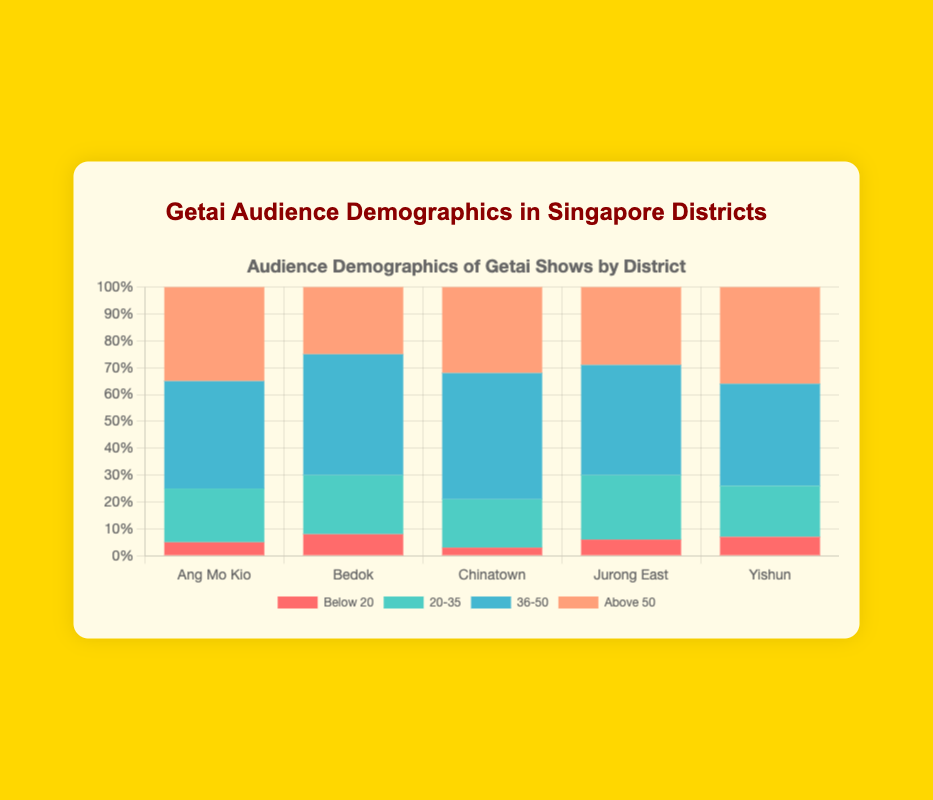Which district has the highest percentage of audience above 50? The highest percentage of audience above 50 is found by looking at the heights of the top-most section of the bars in the stacked bar chart. Yishun has the highest percentage of 36%.
Answer: Yishun Which age group forms the largest percentage in Bedok? Look for the largest section of the Bedok bar, which belongs to the age group 36-50 with 45%.
Answer: 36-50 What is the total percentage of the audience aged below 20 across all districts? Sum the percentages for the 'Below 20' age group for all districts: 5 (Ang Mo Kio) + 8 (Bedok) + 3 (Chinatown) + 6 (Jurong East) + 7 (Yishun) = 29%.
Answer: 29 Which district has the lowest percentage of audience aged 20-35? Check the heights of the second section of each bar (20-35 age group). Chinatown has the lowest percentage in this group at 18%.
Answer: Chinatown What is the difference between the highest and lowest percentage of audience aged 36-50 across all districts? The 36-50 age group has the percentages: Ang Mo Kio (40), Bedok (45), Chinatown (47), Jurong East (41), Yishun (38). The highest is 47 (Chinatown) and the lowest is 38 (Yishun), so the difference is 47 - 38 = 9%.
Answer: 9 In which district is the percentage of audience aged 20-35 greater than the percentage of audience aged above 50? Compare the percentages for 20-35 and above 50 in each district: - Ang Mo Kio: 20% vs 35%
- Bedok: 22% vs 25%
- Chinatown: 18% vs 32%
- Jurong East: 24% vs 29%
- Yishun: 19% vs 36%. None of the districts have a higher percentage of the 20-35 age group compared to above 50.
Answer: None Which age group has the most similar percentage across all districts? Look at the segments with the most consistent heights across districts:
- Below 20: 5, 8, 3, 6, 7 - disparity
- 20-35: 20, 22, 18, 24, 19 - closest
- 36-50: 40, 45, 47, 41, 38 - quite spread
- Above 50: 35, 25, 32, 29, 36. The age group 20-35 has the most similar percentages: 20, 22, 18, 24, 19.
Answer: 20-35 